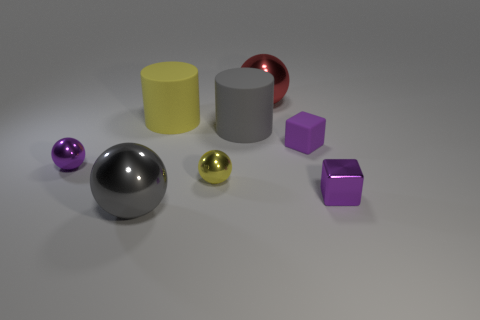Add 1 tiny spheres. How many objects exist? 9 Subtract all big red metal spheres. How many spheres are left? 3 Subtract all cubes. How many objects are left? 6 Subtract all green balls. How many gray cylinders are left? 1 Subtract all red things. Subtract all large yellow shiny blocks. How many objects are left? 7 Add 6 metal balls. How many metal balls are left? 10 Add 5 brown matte spheres. How many brown matte spheres exist? 5 Subtract all purple spheres. How many spheres are left? 3 Subtract 0 green balls. How many objects are left? 8 Subtract 2 balls. How many balls are left? 2 